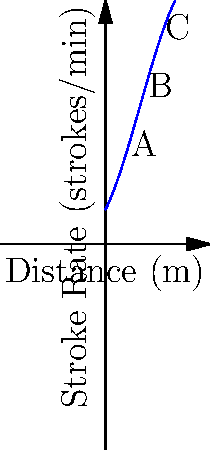The graph shows the relationship between a swimmer's stroke rate and the distance covered during a race. Points A, B, and C represent different stages of the race. At which point is the swimmer's stroke rate increasing at the fastest rate with respect to distance? To determine where the stroke rate is increasing fastest with respect to distance, we need to analyze the rate of change (slope) of the curve at each point:

1. Point A (early in the race):
   The curve has a moderate positive slope, indicating a steady increase in stroke rate.

2. Point B (middle of the race):
   The slope is steeper than at point A, showing a faster increase in stroke rate.

3. Point C (later in the race):
   The slope is the steepest among the three points, indicating the fastest increase in stroke rate.

The rate of change is represented by the derivative of the function. In this polynomial graph, the steepest positive slope occurs at point C, where the curve is rising most rapidly.

This makes sense in a swimming context:
- At the start (A), the swimmer increases stroke rate gradually.
- In the middle (B), they pick up the pace.
- Towards the end (C), they make a final push, rapidly increasing stroke rate for the finish.

Therefore, the stroke rate is increasing fastest at point C.
Answer: Point C 